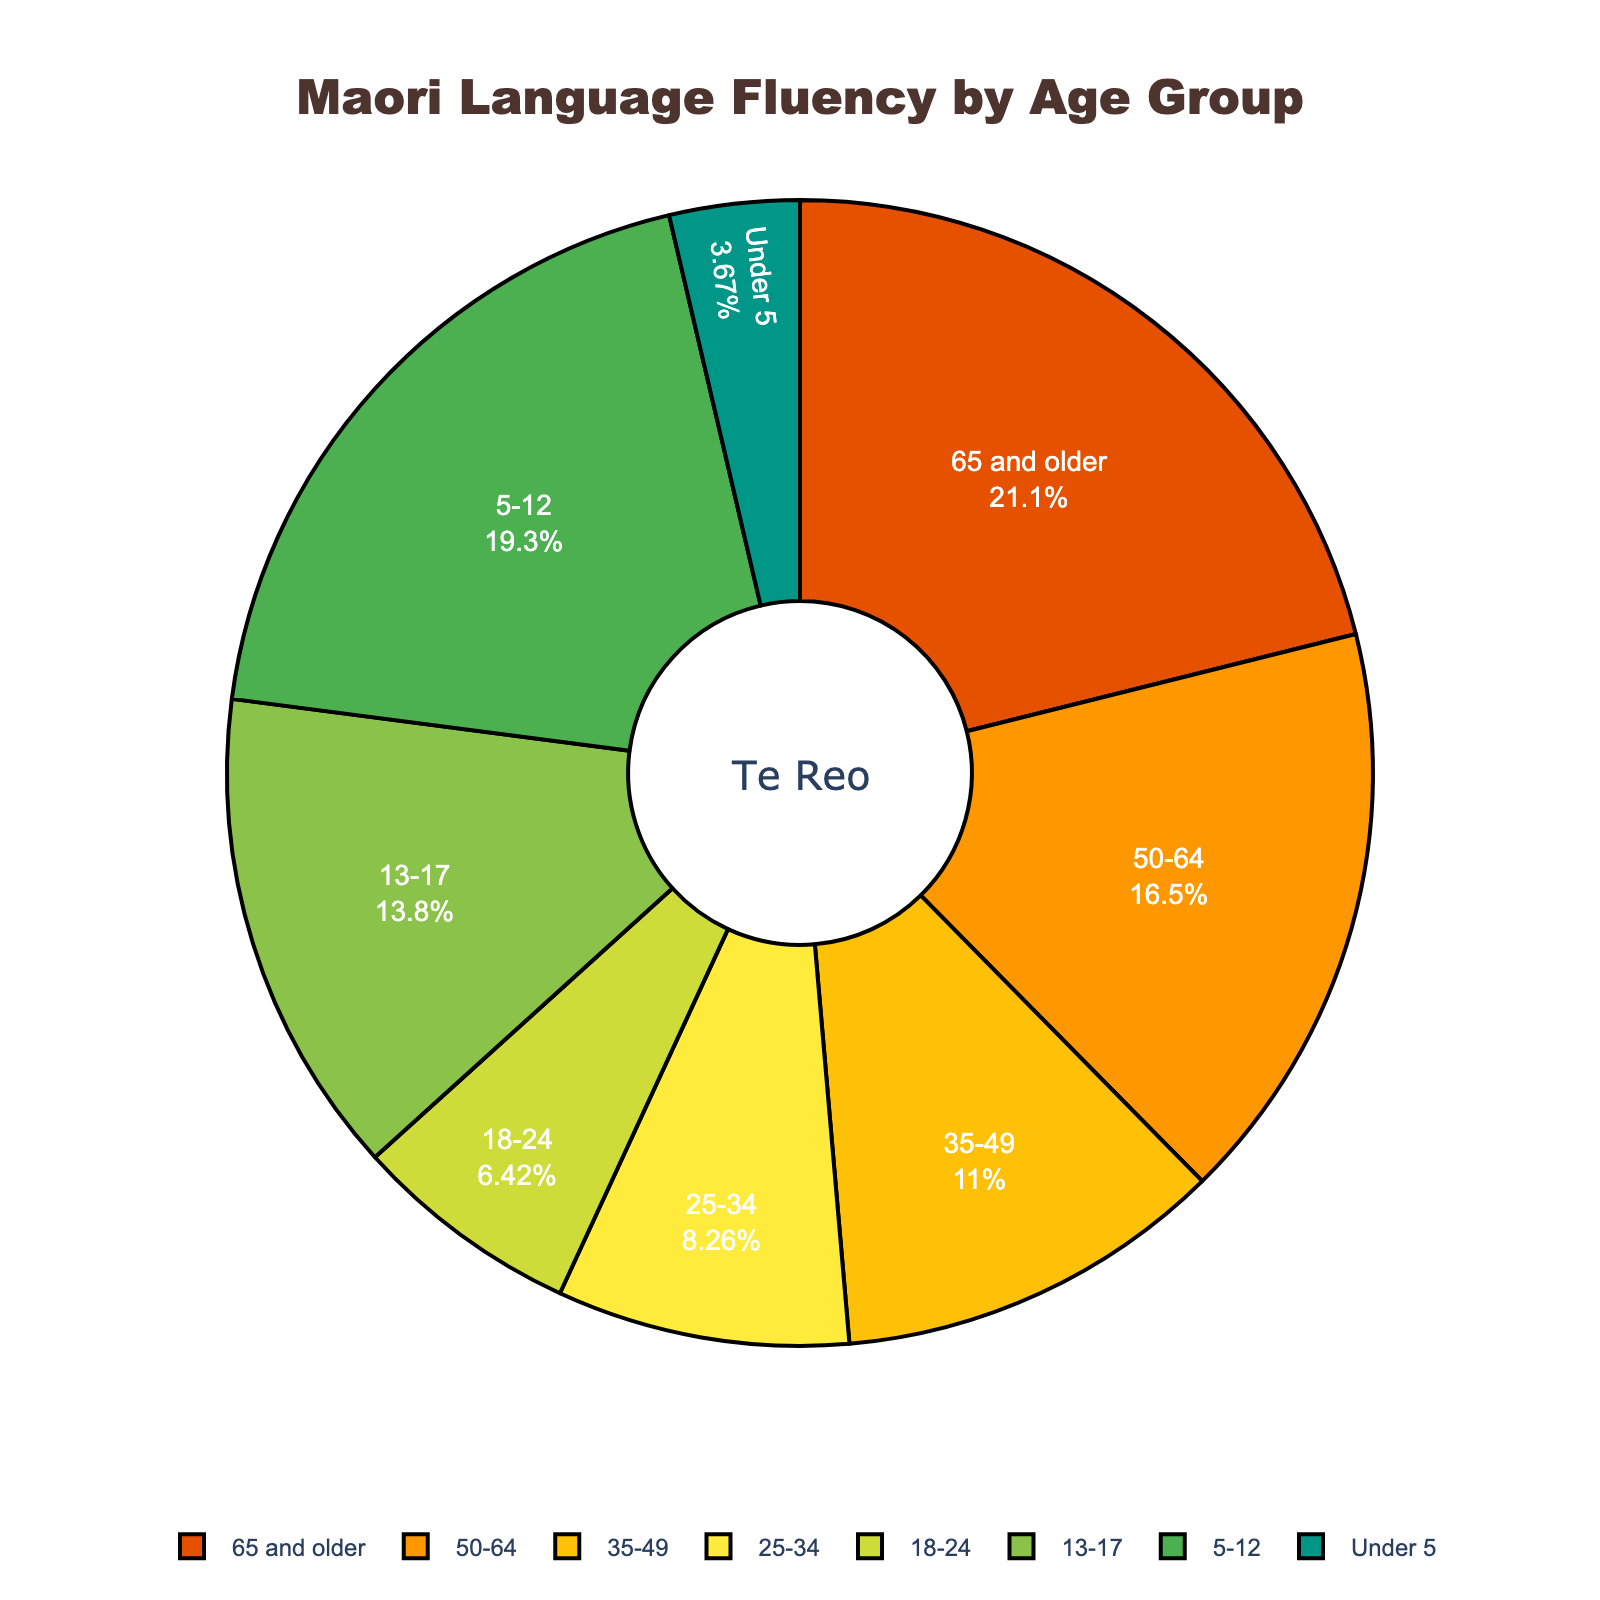What's the largest percentage of Maori language fluency among the age groups? Look at the pie chart and identify the age group with the largest segment. The largest segment represents "65 and older" with 23%.
Answer: 23% Which age group has the smallest percentage of Maori language fluency? Identify the smallest segment in the pie chart, which corresponds to the "Under 5" age group with 4%.
Answer: Under 5 How much larger is the fluency percentage of the "65 and older" group compared to the "Under 5" group? The "65 and older" group has 23% fluency, and the "Under 5" group has 4%. The difference is 23% - 4% = 19%.
Answer: 19% What is the combined percentage of Maori language fluency for the "13-17" and "5-12" age groups? Add the percentages of the "13-17" group (15%) and the "5-12" group (21%). The combined percentage is 15% + 21% = 36%.
Answer: 36% Is the fluency percentage of the "25-34" age group less than that of the "50-64" age group? Compare the two percentages: "25-34" age group has 9% and "50-64" age group has 18%. Since 9% is less than 18%, the answer is yes.
Answer: Yes Among the age groups "35-49" and "25-34", which one has a higher percentage of Maori language fluency? Compare the percentages of "35-49" (12%) and "25-34" (9%). "35-49" has a higher percentage.
Answer: 35-49 What is the average percentage of Maori language fluency for the age groups: "18-24", "5-12", and "Under 5"? Calculate the average by adding the percentages (7% + 21% + 4%) and dividing by the number of groups (3): (7 + 21 + 4) / 3 = 32 / 3 = approximately 10.67%.
Answer: 10.67% What percentage of Maori language fluency is accounted for by the age groups under 18 years old? Add percentages for "Under 5" (4%), "5-12" (21%), and "13-17" (15%): 4% + 21% + 15% = 40%.
Answer: 40% Is the fluency of the "13-17" age group greater than the combined fluency percentages of the "18-24" and "Under 5" age groups? Compare the percentage of "13-17" (15%) with the combined percentages of "18-24" (7%) and "Under 5" (4%): 7% + 4% = 11%. Since 15% is greater than 11%, the answer is yes.
Answer: Yes 